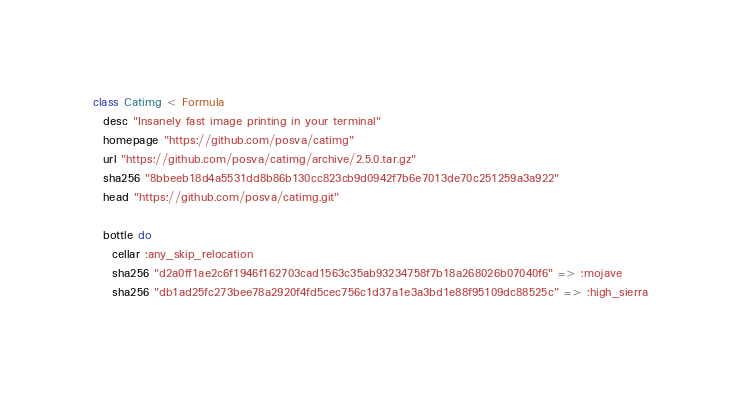Convert code to text. <code><loc_0><loc_0><loc_500><loc_500><_Ruby_>class Catimg < Formula
  desc "Insanely fast image printing in your terminal"
  homepage "https://github.com/posva/catimg"
  url "https://github.com/posva/catimg/archive/2.5.0.tar.gz"
  sha256 "8bbeeb18d4a5531dd8b86b130cc823cb9d0942f7b6e7013de70c251259a3a922"
  head "https://github.com/posva/catimg.git"

  bottle do
    cellar :any_skip_relocation
    sha256 "d2a0ff1ae2c6f1946f162703cad1563c35ab93234758f7b18a268026b07040f6" => :mojave
    sha256 "db1ad25fc273bee78a2920f4fd5cec756c1d37a1e3a3bd1e88f95109dc88525c" => :high_sierra</code> 